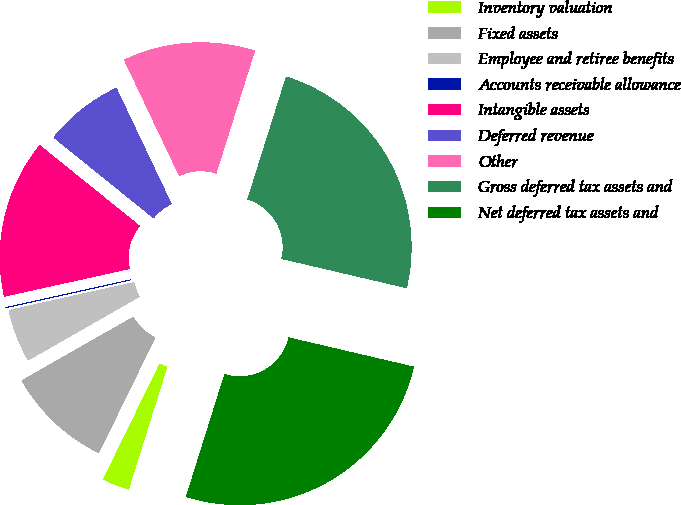Convert chart. <chart><loc_0><loc_0><loc_500><loc_500><pie_chart><fcel>Inventory valuation<fcel>Fixed assets<fcel>Employee and retiree benefits<fcel>Accounts receivable allowance<fcel>Intangible assets<fcel>Deferred revenue<fcel>Other<fcel>Gross deferred tax assets and<fcel>Net deferred tax assets and<nl><fcel>2.39%<fcel>9.52%<fcel>4.76%<fcel>0.01%<fcel>14.28%<fcel>7.14%<fcel>11.9%<fcel>23.8%<fcel>26.18%<nl></chart> 